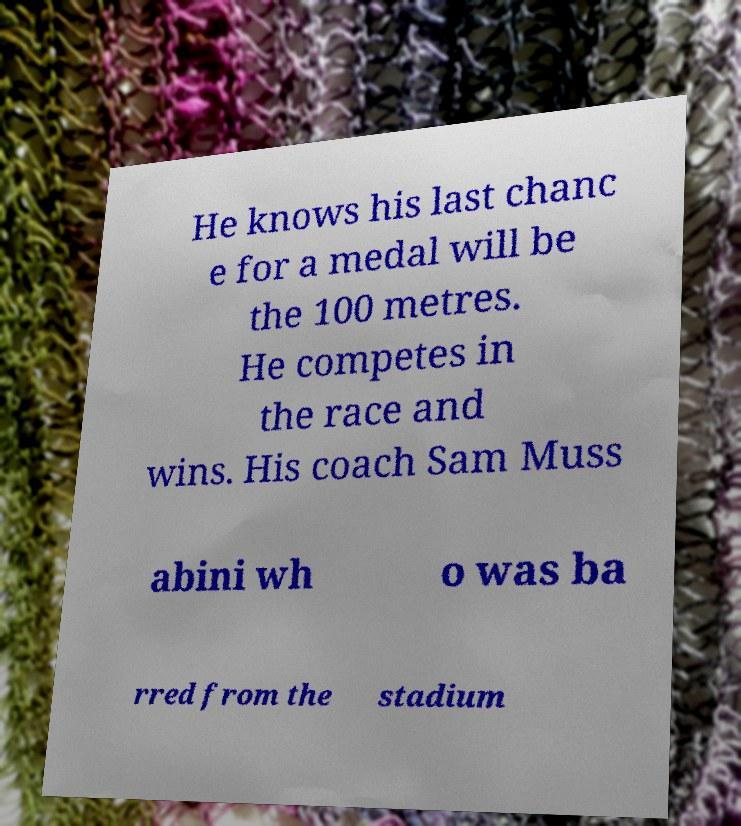Please read and relay the text visible in this image. What does it say? He knows his last chanc e for a medal will be the 100 metres. He competes in the race and wins. His coach Sam Muss abini wh o was ba rred from the stadium 